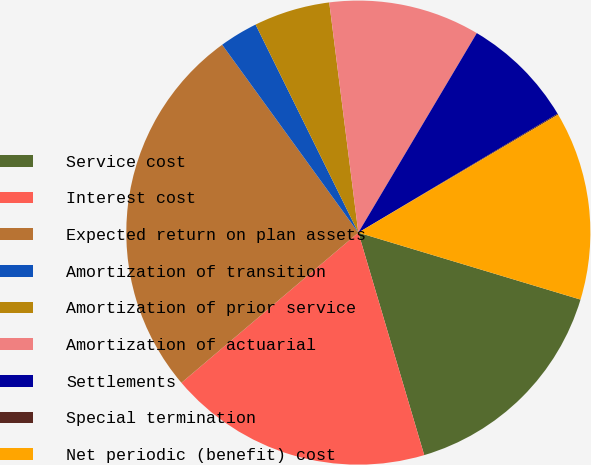<chart> <loc_0><loc_0><loc_500><loc_500><pie_chart><fcel>Service cost<fcel>Interest cost<fcel>Expected return on plan assets<fcel>Amortization of transition<fcel>Amortization of prior service<fcel>Amortization of actuarial<fcel>Settlements<fcel>Special termination<fcel>Net periodic (benefit) cost<nl><fcel>15.76%<fcel>18.38%<fcel>26.22%<fcel>2.68%<fcel>5.3%<fcel>10.53%<fcel>7.91%<fcel>0.07%<fcel>13.15%<nl></chart> 